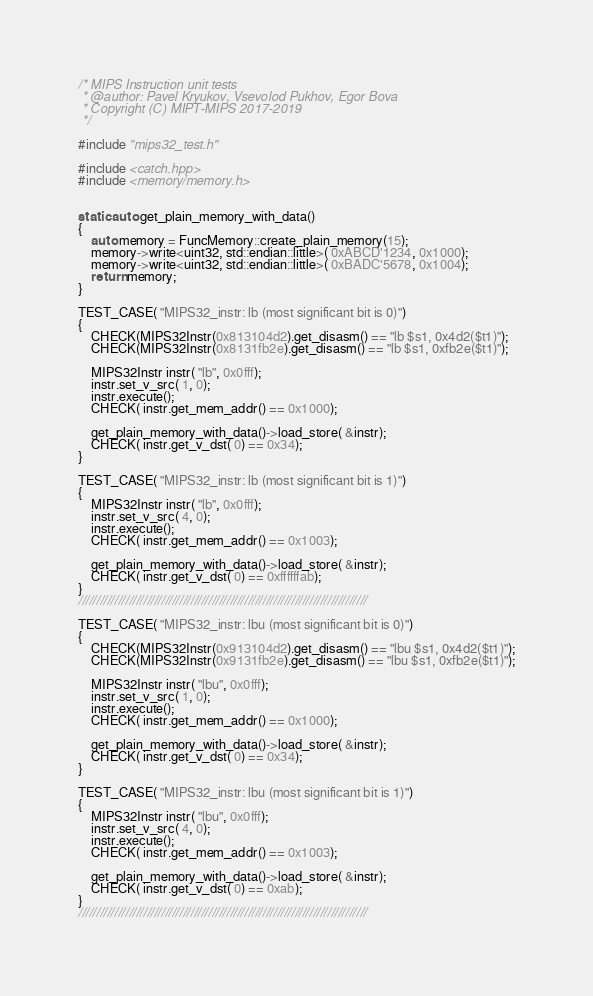<code> <loc_0><loc_0><loc_500><loc_500><_C++_>/* MIPS Instruction unit tests
 * @author: Pavel Kryukov, Vsevolod Pukhov, Egor Bova
 * Copyright (C) MIPT-MIPS 2017-2019
 */

#include "mips32_test.h"

#include <catch.hpp>
#include <memory/memory.h>


static auto get_plain_memory_with_data()
{
    auto memory = FuncMemory::create_plain_memory(15);
    memory->write<uint32, std::endian::little>( 0xABCD'1234, 0x1000);
    memory->write<uint32, std::endian::little>( 0xBADC'5678, 0x1004);
    return memory;
}

TEST_CASE( "MIPS32_instr: lb (most significant bit is 0)")
{
    CHECK(MIPS32Instr(0x813104d2).get_disasm() == "lb $s1, 0x4d2($t1)");
    CHECK(MIPS32Instr(0x8131fb2e).get_disasm() == "lb $s1, 0xfb2e($t1)");

    MIPS32Instr instr( "lb", 0x0fff);
    instr.set_v_src( 1, 0);
    instr.execute();
    CHECK( instr.get_mem_addr() == 0x1000);

    get_plain_memory_with_data()->load_store( &instr);
    CHECK( instr.get_v_dst( 0) == 0x34);
}

TEST_CASE( "MIPS32_instr: lb (most significant bit is 1)")
{
    MIPS32Instr instr( "lb", 0x0fff);
    instr.set_v_src( 4, 0);
    instr.execute();
    CHECK( instr.get_mem_addr() == 0x1003);

    get_plain_memory_with_data()->load_store( &instr);
    CHECK( instr.get_v_dst( 0) == 0xffffffab);
}
////////////////////////////////////////////////////////////////////////////////

TEST_CASE( "MIPS32_instr: lbu (most significant bit is 0)")
{
    CHECK(MIPS32Instr(0x913104d2).get_disasm() == "lbu $s1, 0x4d2($t1)");
    CHECK(MIPS32Instr(0x9131fb2e).get_disasm() == "lbu $s1, 0xfb2e($t1)");

    MIPS32Instr instr( "lbu", 0x0fff);
    instr.set_v_src( 1, 0);
    instr.execute();
    CHECK( instr.get_mem_addr() == 0x1000);

    get_plain_memory_with_data()->load_store( &instr);
    CHECK( instr.get_v_dst( 0) == 0x34);
}

TEST_CASE( "MIPS32_instr: lbu (most significant bit is 1)")
{
    MIPS32Instr instr( "lbu", 0x0fff);
    instr.set_v_src( 4, 0);
    instr.execute();
    CHECK( instr.get_mem_addr() == 0x1003);

    get_plain_memory_with_data()->load_store( &instr);
    CHECK( instr.get_v_dst( 0) == 0xab);
}
////////////////////////////////////////////////////////////////////////////////
</code> 